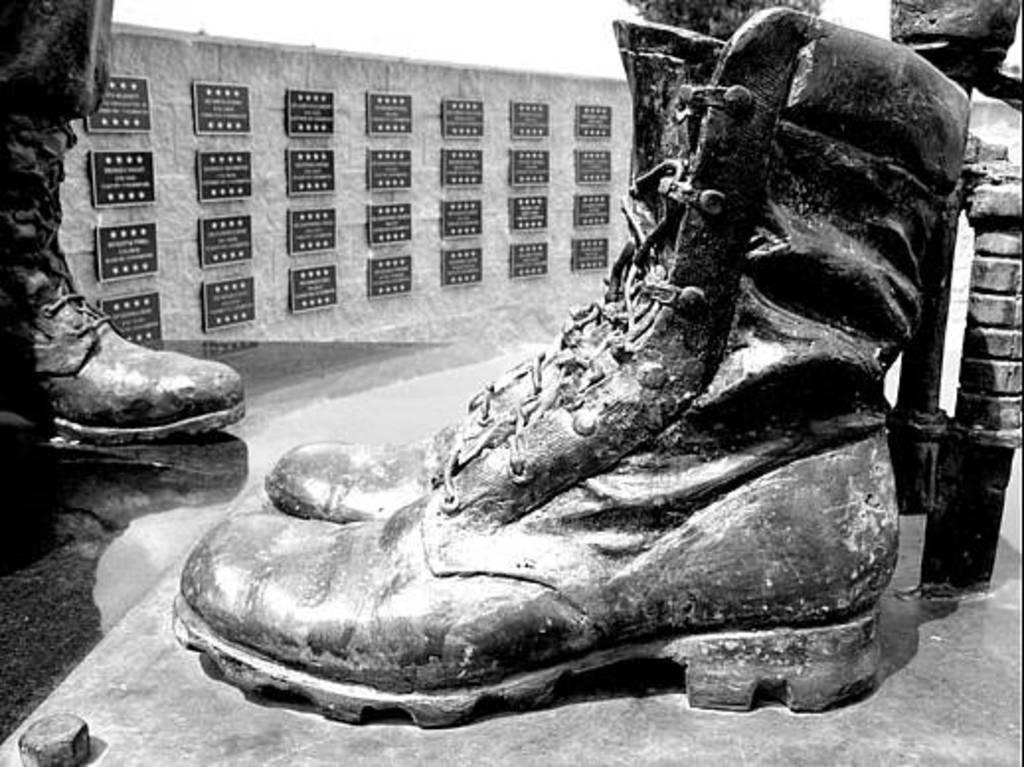What is the color scheme of the image? The image is black and white. What type of objects are featured in the image? There are statues of shoes in the image. Can you describe any human elements in the image? A person's leg is depicted in the image. What can be seen in the background of the image? There are frames attached to the wall in the background of the image. How much sugar is present in the image? There is no sugar present in the image, as it features statues of shoes, a person's leg, and frames on the wall. What memories can be recalled from the image? The image does not depict any specific memories or events, as it is a static representation of statues, a leg, and frames. 